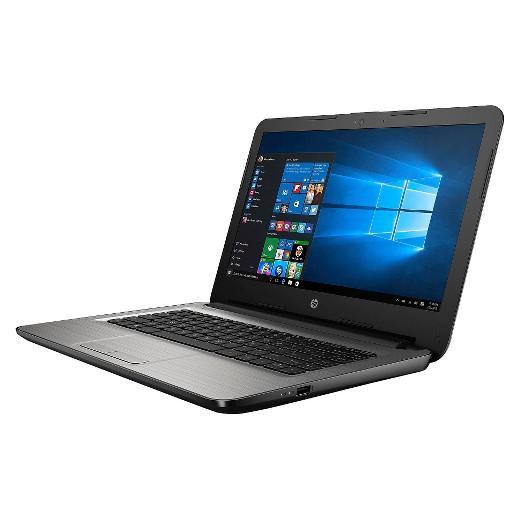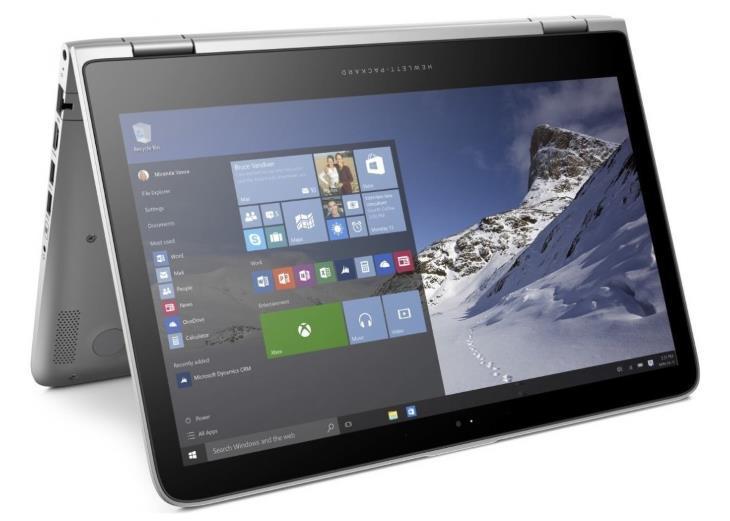The first image is the image on the left, the second image is the image on the right. Considering the images on both sides, is "One of the laptops is standing tent-like, with an image displaying outward on the inverted screen." valid? Answer yes or no. Yes. The first image is the image on the left, the second image is the image on the right. Analyze the images presented: Is the assertion "The image on the left shows a laptop with the keyboard not visible so it can be used as a tablet." valid? Answer yes or no. No. 